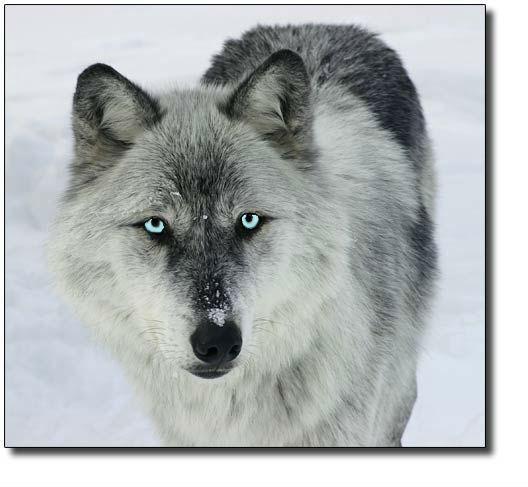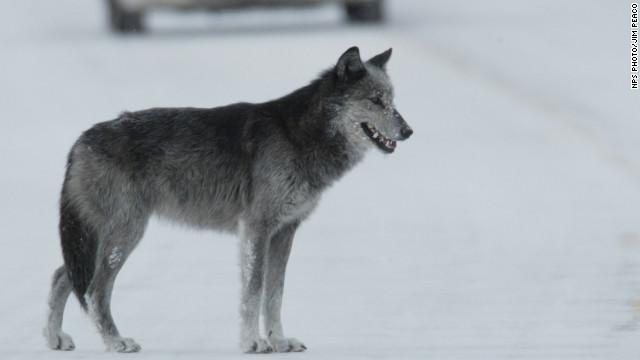The first image is the image on the left, the second image is the image on the right. Assess this claim about the two images: "The animal in the image on the left is moving left.". Correct or not? Answer yes or no. No. 